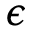Convert formula to latex. <formula><loc_0><loc_0><loc_500><loc_500>\epsilon</formula> 